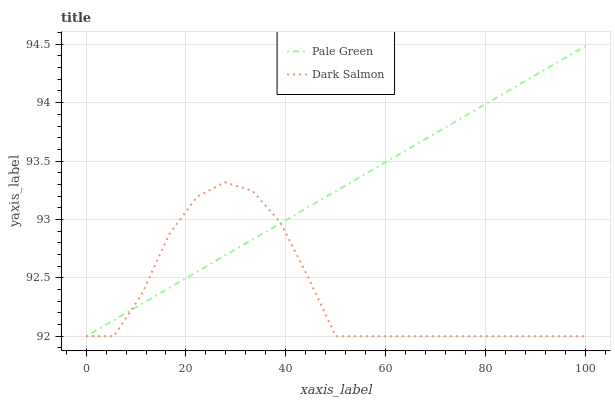Does Dark Salmon have the minimum area under the curve?
Answer yes or no. Yes. Does Pale Green have the maximum area under the curve?
Answer yes or no. Yes. Does Dark Salmon have the maximum area under the curve?
Answer yes or no. No. Is Pale Green the smoothest?
Answer yes or no. Yes. Is Dark Salmon the roughest?
Answer yes or no. Yes. Is Dark Salmon the smoothest?
Answer yes or no. No. Does Pale Green have the lowest value?
Answer yes or no. Yes. Does Pale Green have the highest value?
Answer yes or no. Yes. Does Dark Salmon have the highest value?
Answer yes or no. No. Does Pale Green intersect Dark Salmon?
Answer yes or no. Yes. Is Pale Green less than Dark Salmon?
Answer yes or no. No. Is Pale Green greater than Dark Salmon?
Answer yes or no. No. 